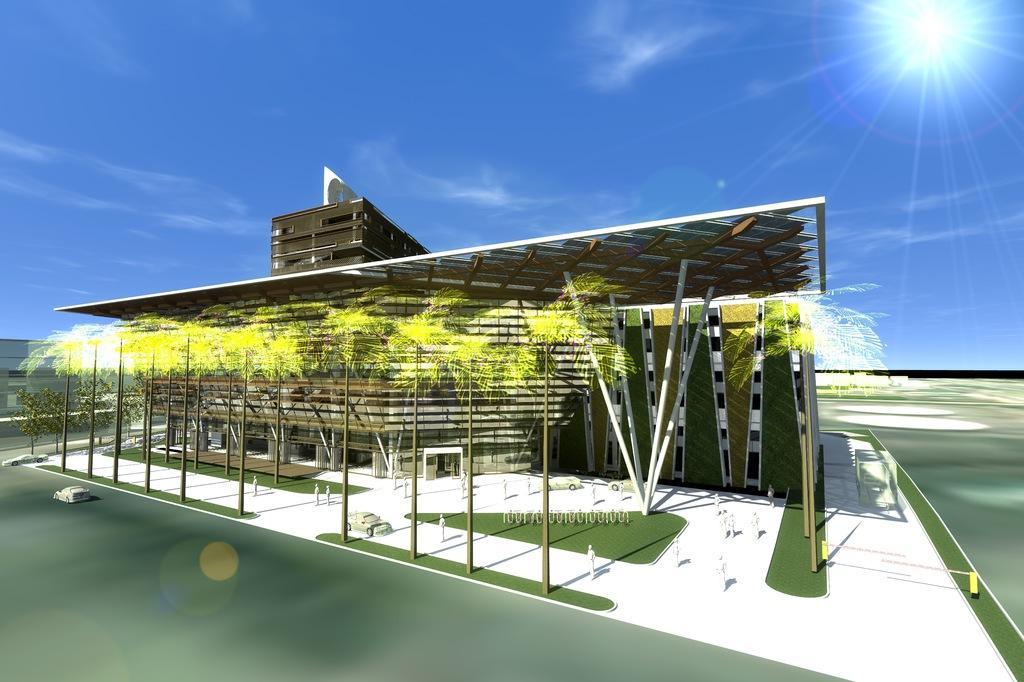In one or two sentences, can you explain what this image depicts? This image is a blueprint. In this image we can see building, person and trees. In the background we can see sky and clouds. At the bottom of the image there are cars on the road. 